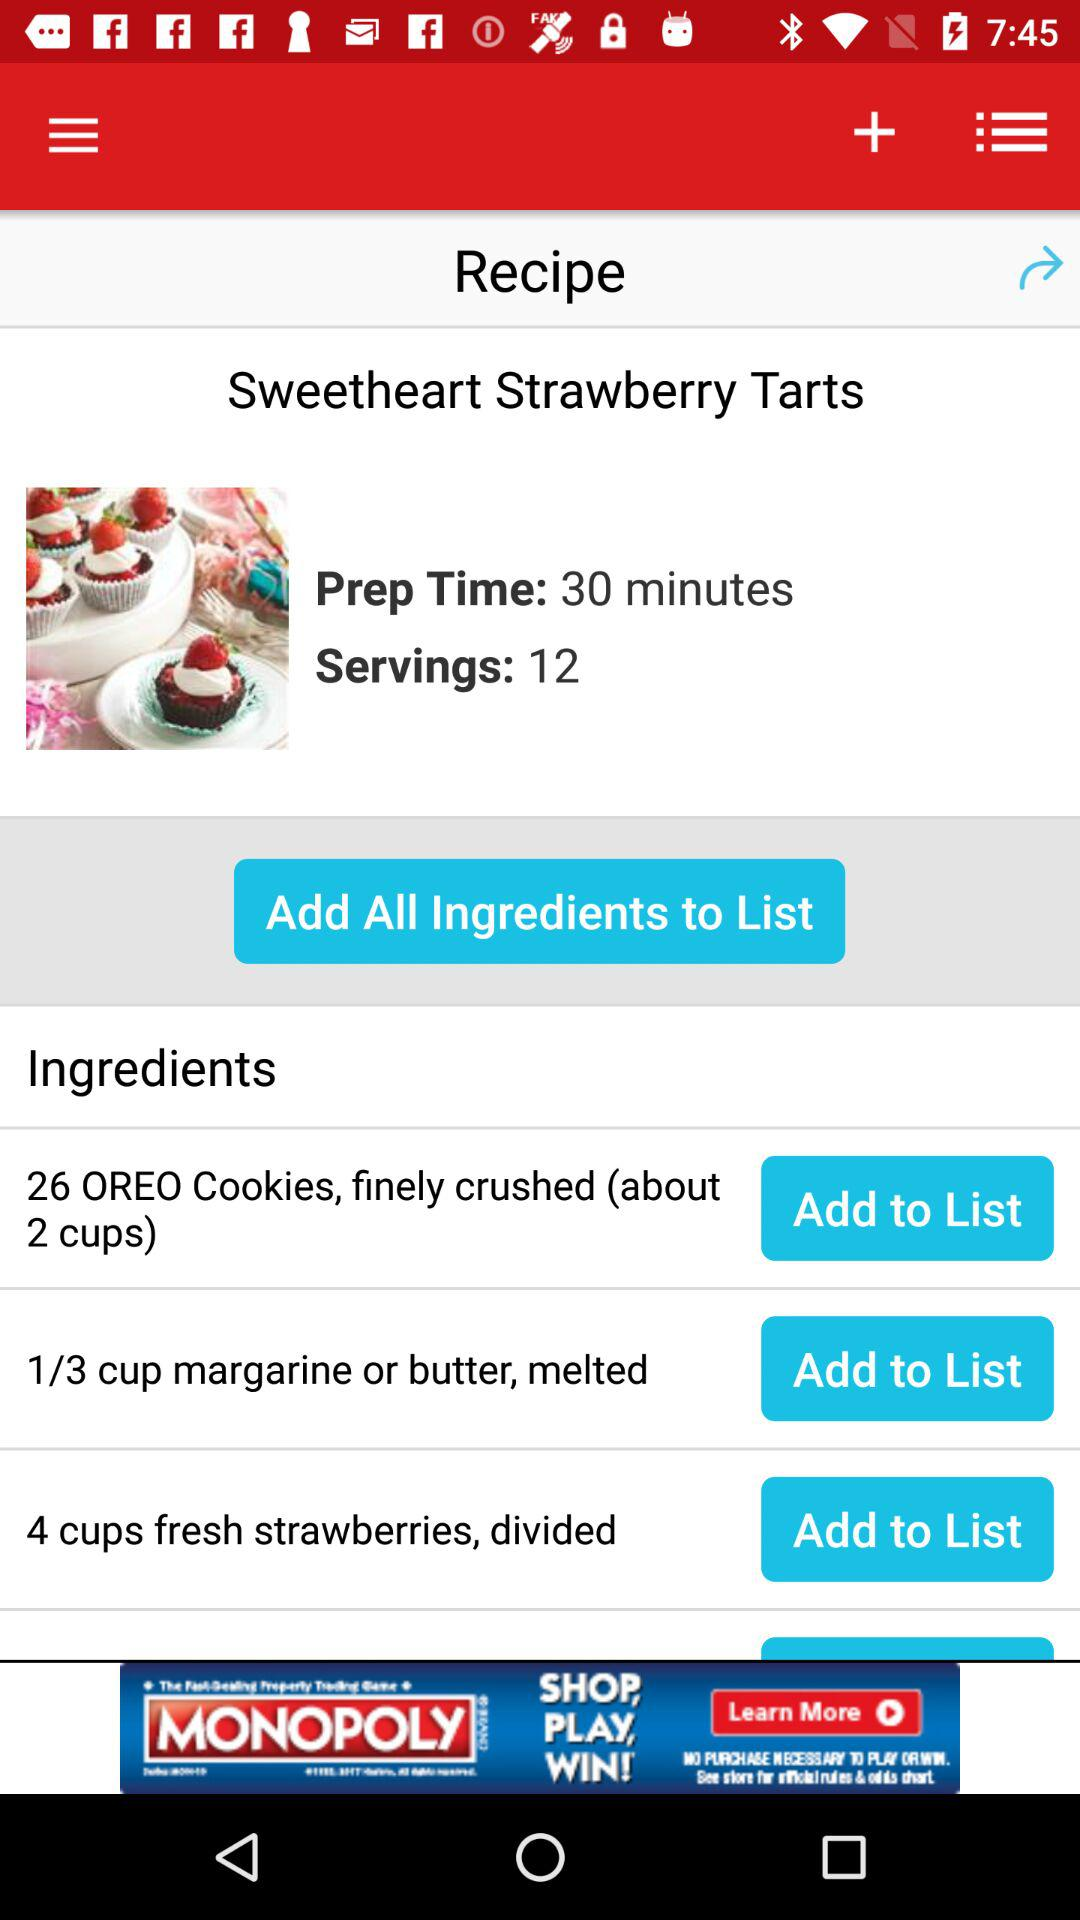What is the name of the recipe? The name of the recipe is "Sweetheart Strawberry Tarts". 